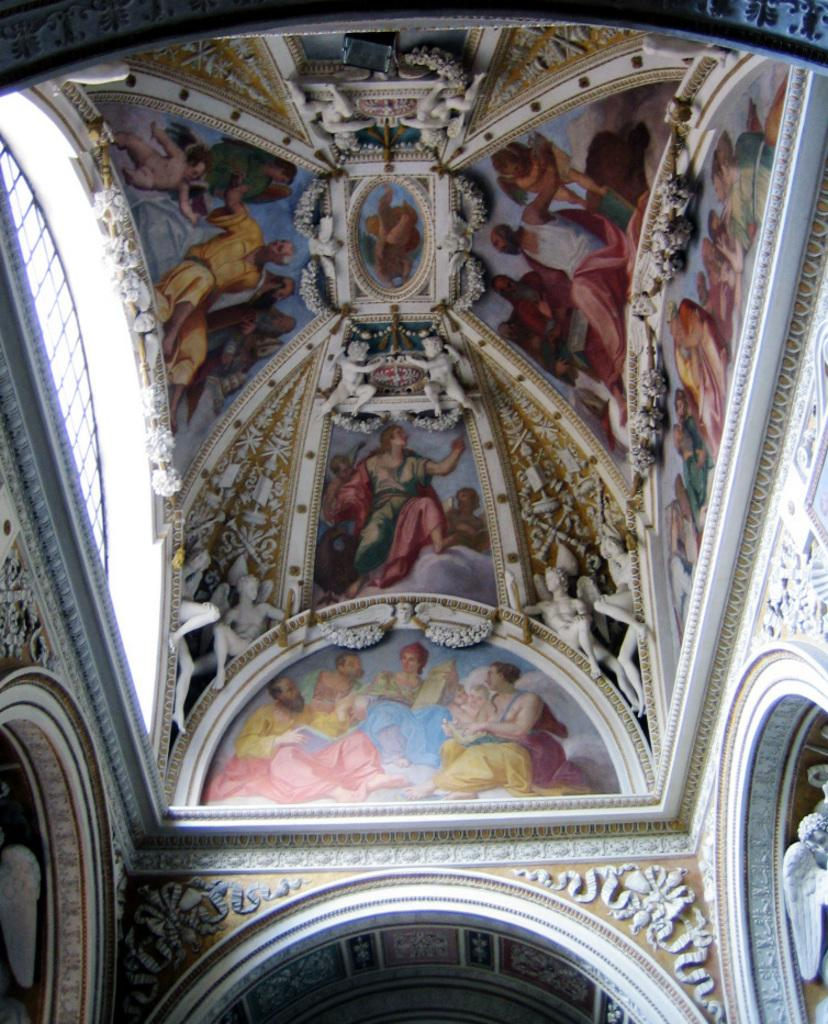What architectural feature can be seen in the image? There are arches in the image. What type of artwork is present on the walls in the image? There are paintings on the walls in the image. What type of arithmetic problem is being solved on the walls in the image? There is no arithmetic problem present on the walls in the image; there are only paintings. Can you see any squirrels in the image? There are no squirrels present in the image. 